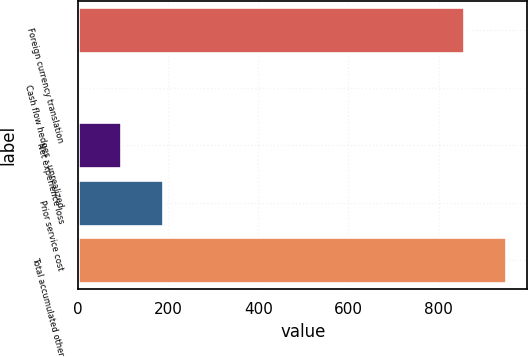Convert chart to OTSL. <chart><loc_0><loc_0><loc_500><loc_500><bar_chart><fcel>Foreign currency translation<fcel>Cash flow hedges - unrealized<fcel>Net experience loss<fcel>Prior service cost<fcel>Total accumulated other<nl><fcel>856<fcel>1<fcel>94.5<fcel>188<fcel>949.5<nl></chart> 